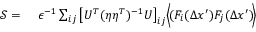<formula> <loc_0><loc_0><loc_500><loc_500>\begin{array} { r l } { \mathcal { S } = } & { \epsilon ^ { - 1 } } \sum _ { i j } \left [ U ^ { T } ( \eta \eta ^ { T } ) ^ { - 1 } U \right ] _ { i j } \left \langle \, ( F _ { i } ( \Delta x ^ { \prime } ) F _ { j } ( \Delta { x } ^ { \prime } ) \, \right \rangle } \end{array}</formula> 